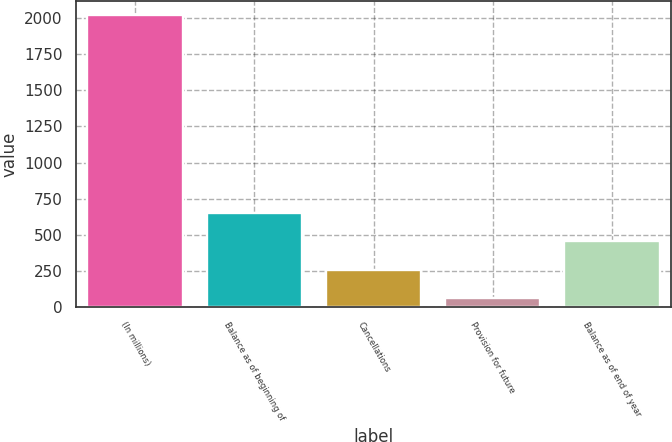<chart> <loc_0><loc_0><loc_500><loc_500><bar_chart><fcel>(In millions)<fcel>Balance as of beginning of<fcel>Cancellations<fcel>Provision for future<fcel>Balance as of end of year<nl><fcel>2019<fcel>650.43<fcel>259.41<fcel>63.9<fcel>454.92<nl></chart> 